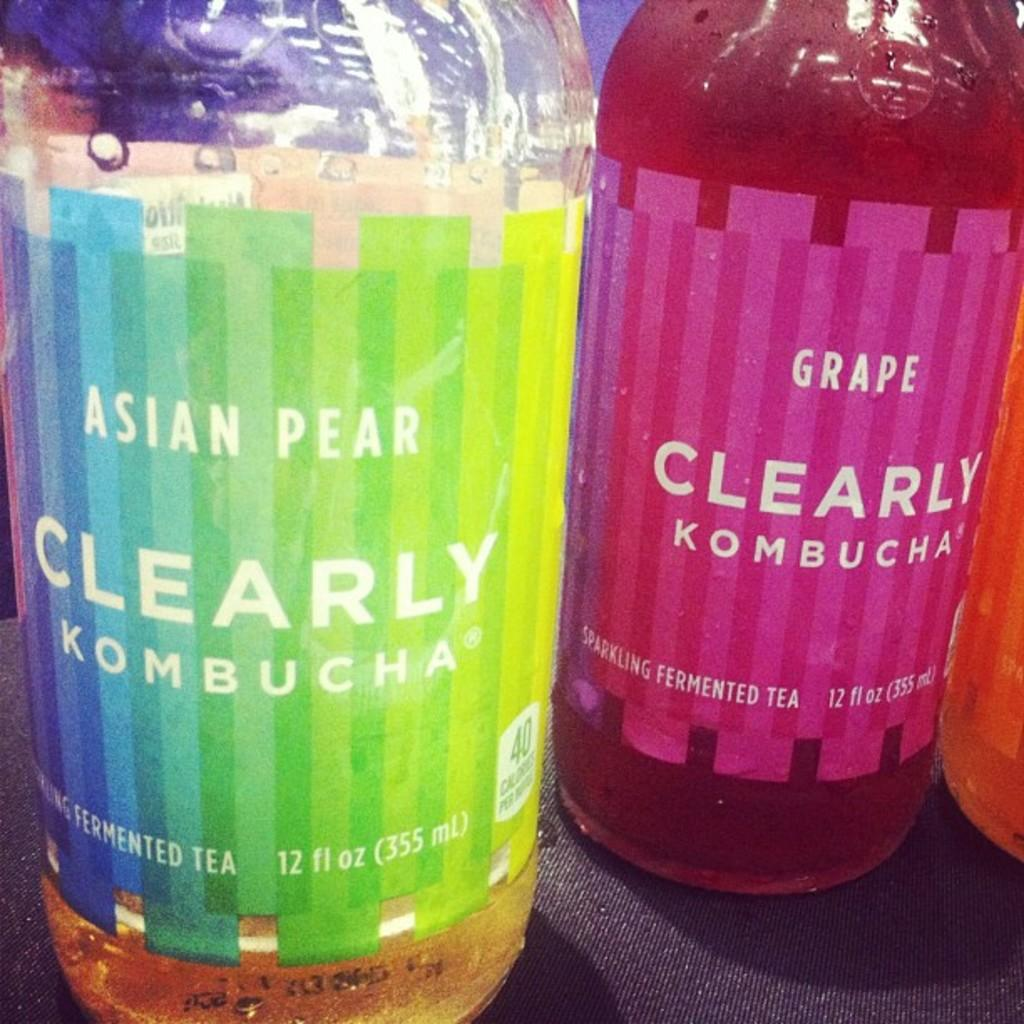How many bottles are visible in the image? There are three bottles in the foreground of the image. What is the color of the surface on which the bottles are placed? The bottles are on a black surface. What is the bottles' position or arrangement in the image? The bottles are wrapped around something. What type of egg is being cooked in the wilderness in the image? There is no egg or wilderness present in the image; it features three bottles wrapped around something on a black surface. 